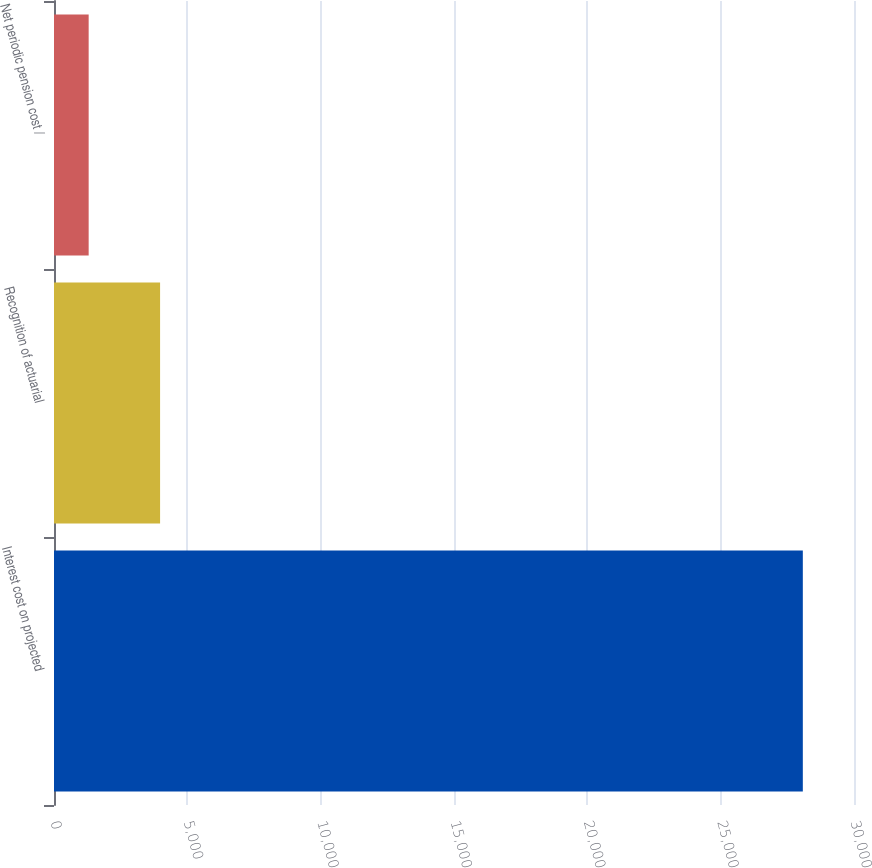Convert chart to OTSL. <chart><loc_0><loc_0><loc_500><loc_500><bar_chart><fcel>Interest cost on projected<fcel>Recognition of actuarial<fcel>Net periodic pension cost /<nl><fcel>28081<fcel>3978.1<fcel>1300<nl></chart> 